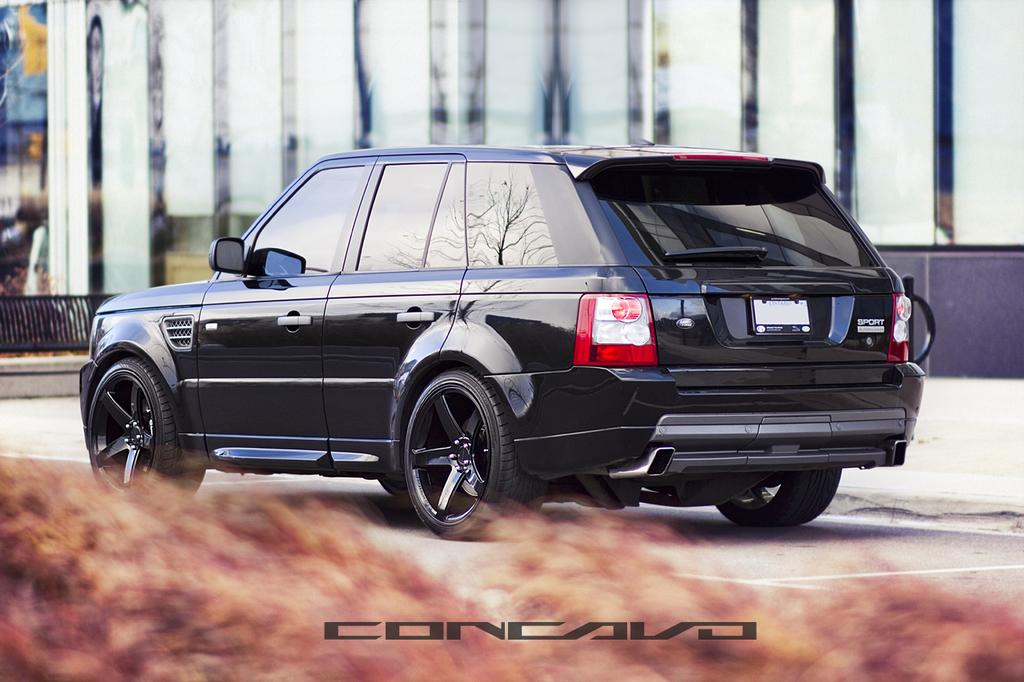What color is the car in the image? The car in the image is black. Where is the car located in the image? The car is on the land in the image. What can be found at the bottom of the image? There is text on the bottom of the image. What is present in the background of the image? There is a black color railing in the background. On which side of the image is the railing located? The railing is on the left side of the image. What type of sofa can be seen in the image? There is no sofa present in the image. What kind of string is attached to the car in the image? There is no string attached to the car in the image. 